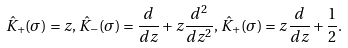<formula> <loc_0><loc_0><loc_500><loc_500>\hat { K } _ { + } ( \sigma ) = z , \, \hat { K } _ { - } ( \sigma ) = \frac { d } { d z } + z \frac { d ^ { 2 } } { d z ^ { 2 } } , \, \hat { K } _ { + } ( \sigma ) = z \frac { d } { d z } + \frac { 1 } { 2 } .</formula> 